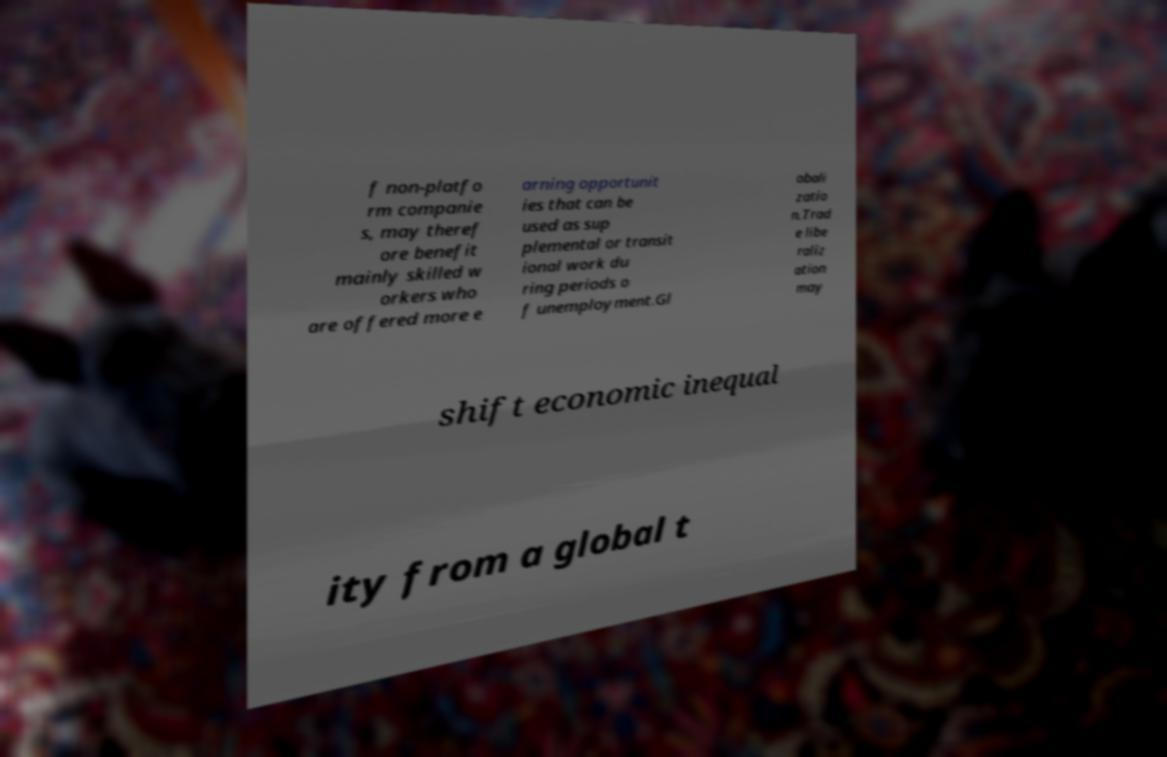Please read and relay the text visible in this image. What does it say? f non-platfo rm companie s, may theref ore benefit mainly skilled w orkers who are offered more e arning opportunit ies that can be used as sup plemental or transit ional work du ring periods o f unemployment.Gl obali zatio n.Trad e libe raliz ation may shift economic inequal ity from a global t 